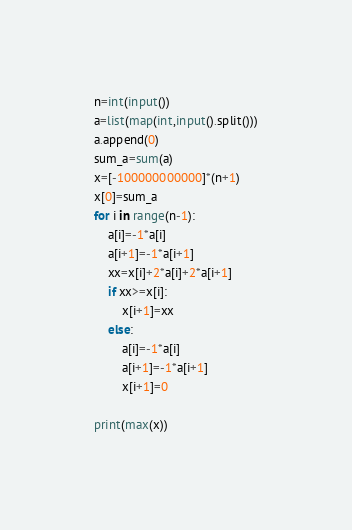Convert code to text. <code><loc_0><loc_0><loc_500><loc_500><_Python_>n=int(input())
a=list(map(int,input().split()))
a.append(0)
sum_a=sum(a)
x=[-100000000000]*(n+1)
x[0]=sum_a
for i in range(n-1):
    a[i]=-1*a[i]
    a[i+1]=-1*a[i+1]
    xx=x[i]+2*a[i]+2*a[i+1]
    if xx>=x[i]:
        x[i+1]=xx
    else:
        a[i]=-1*a[i]
        a[i+1]=-1*a[i+1]
        x[i+1]=0

print(max(x))
</code> 